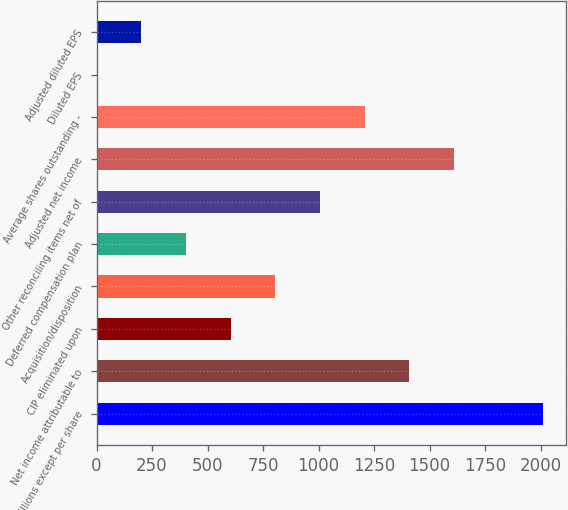Convert chart to OTSL. <chart><loc_0><loc_0><loc_500><loc_500><bar_chart><fcel>in millions except per share<fcel>Net income attributable to<fcel>CIP eliminated upon<fcel>Acquisition/disposition<fcel>Deferred compensation plan<fcel>Other reconciling items net of<fcel>Adjusted net income<fcel>Average shares outstanding -<fcel>Diluted EPS<fcel>Adjusted diluted EPS<nl><fcel>2012<fcel>1408.84<fcel>604.64<fcel>805.69<fcel>403.59<fcel>1006.74<fcel>1609.89<fcel>1207.79<fcel>1.49<fcel>202.54<nl></chart> 